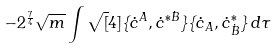Convert formula to latex. <formula><loc_0><loc_0><loc_500><loc_500>- 2 ^ { \frac { 7 } { 4 } } \sqrt { m } \int { \sqrt { [ } 4 ] { \{ \dot { c } ^ { A } , \dot { c } ^ { * \dot { B } } \} \{ \dot { c } _ { A } , \dot { c } ^ { * } _ { \dot { B } } \} } \, d \tau }</formula> 